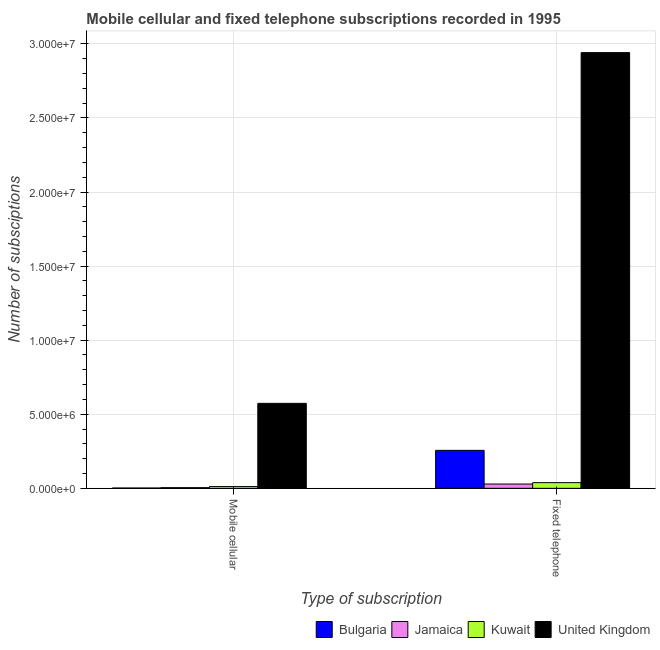How many different coloured bars are there?
Provide a short and direct response. 4. How many groups of bars are there?
Your answer should be compact. 2. Are the number of bars on each tick of the X-axis equal?
Give a very brief answer. Yes. How many bars are there on the 1st tick from the left?
Provide a succinct answer. 4. What is the label of the 2nd group of bars from the left?
Offer a terse response. Fixed telephone. What is the number of mobile cellular subscriptions in Jamaica?
Your answer should be compact. 4.51e+04. Across all countries, what is the maximum number of mobile cellular subscriptions?
Your answer should be very brief. 5.74e+06. Across all countries, what is the minimum number of fixed telephone subscriptions?
Provide a succinct answer. 2.90e+05. In which country was the number of fixed telephone subscriptions minimum?
Provide a short and direct response. Jamaica. What is the total number of mobile cellular subscriptions in the graph?
Your response must be concise. 5.92e+06. What is the difference between the number of fixed telephone subscriptions in United Kingdom and that in Bulgaria?
Give a very brief answer. 2.68e+07. What is the difference between the number of mobile cellular subscriptions in United Kingdom and the number of fixed telephone subscriptions in Jamaica?
Your answer should be compact. 5.45e+06. What is the average number of fixed telephone subscriptions per country?
Your response must be concise. 8.16e+06. What is the difference between the number of mobile cellular subscriptions and number of fixed telephone subscriptions in Jamaica?
Provide a short and direct response. -2.45e+05. In how many countries, is the number of fixed telephone subscriptions greater than 21000000 ?
Keep it short and to the point. 1. What is the ratio of the number of fixed telephone subscriptions in United Kingdom to that in Kuwait?
Keep it short and to the point. 76.94. Is the number of mobile cellular subscriptions in United Kingdom less than that in Jamaica?
Your answer should be compact. No. In how many countries, is the number of fixed telephone subscriptions greater than the average number of fixed telephone subscriptions taken over all countries?
Your response must be concise. 1. What does the 2nd bar from the left in Fixed telephone represents?
Your response must be concise. Jamaica. What does the 2nd bar from the right in Fixed telephone represents?
Provide a succinct answer. Kuwait. What is the difference between two consecutive major ticks on the Y-axis?
Offer a terse response. 5.00e+06. How many legend labels are there?
Your answer should be very brief. 4. How are the legend labels stacked?
Offer a terse response. Horizontal. What is the title of the graph?
Keep it short and to the point. Mobile cellular and fixed telephone subscriptions recorded in 1995. Does "Samoa" appear as one of the legend labels in the graph?
Offer a terse response. No. What is the label or title of the X-axis?
Ensure brevity in your answer.  Type of subscription. What is the label or title of the Y-axis?
Give a very brief answer. Number of subsciptions. What is the Number of subsciptions of Bulgaria in Mobile cellular?
Provide a short and direct response. 2.09e+04. What is the Number of subsciptions in Jamaica in Mobile cellular?
Provide a short and direct response. 4.51e+04. What is the Number of subsciptions in Kuwait in Mobile cellular?
Provide a short and direct response. 1.18e+05. What is the Number of subsciptions in United Kingdom in Mobile cellular?
Offer a very short reply. 5.74e+06. What is the Number of subsciptions of Bulgaria in Fixed telephone?
Provide a succinct answer. 2.56e+06. What is the Number of subsciptions of Jamaica in Fixed telephone?
Your answer should be compact. 2.90e+05. What is the Number of subsciptions in Kuwait in Fixed telephone?
Give a very brief answer. 3.82e+05. What is the Number of subsciptions of United Kingdom in Fixed telephone?
Ensure brevity in your answer.  2.94e+07. Across all Type of subscription, what is the maximum Number of subsciptions in Bulgaria?
Your answer should be very brief. 2.56e+06. Across all Type of subscription, what is the maximum Number of subsciptions of Jamaica?
Give a very brief answer. 2.90e+05. Across all Type of subscription, what is the maximum Number of subsciptions in Kuwait?
Your answer should be very brief. 3.82e+05. Across all Type of subscription, what is the maximum Number of subsciptions in United Kingdom?
Your answer should be compact. 2.94e+07. Across all Type of subscription, what is the minimum Number of subsciptions in Bulgaria?
Your answer should be very brief. 2.09e+04. Across all Type of subscription, what is the minimum Number of subsciptions of Jamaica?
Your response must be concise. 4.51e+04. Across all Type of subscription, what is the minimum Number of subsciptions of Kuwait?
Provide a short and direct response. 1.18e+05. Across all Type of subscription, what is the minimum Number of subsciptions in United Kingdom?
Provide a short and direct response. 5.74e+06. What is the total Number of subsciptions in Bulgaria in the graph?
Ensure brevity in your answer.  2.58e+06. What is the total Number of subsciptions of Jamaica in the graph?
Your response must be concise. 3.35e+05. What is the total Number of subsciptions of Kuwait in the graph?
Give a very brief answer. 5.00e+05. What is the total Number of subsciptions in United Kingdom in the graph?
Your answer should be compact. 3.51e+07. What is the difference between the Number of subsciptions of Bulgaria in Mobile cellular and that in Fixed telephone?
Keep it short and to the point. -2.54e+06. What is the difference between the Number of subsciptions in Jamaica in Mobile cellular and that in Fixed telephone?
Offer a very short reply. -2.45e+05. What is the difference between the Number of subsciptions in Kuwait in Mobile cellular and that in Fixed telephone?
Provide a short and direct response. -2.65e+05. What is the difference between the Number of subsciptions in United Kingdom in Mobile cellular and that in Fixed telephone?
Your answer should be very brief. -2.37e+07. What is the difference between the Number of subsciptions of Bulgaria in Mobile cellular and the Number of subsciptions of Jamaica in Fixed telephone?
Give a very brief answer. -2.69e+05. What is the difference between the Number of subsciptions in Bulgaria in Mobile cellular and the Number of subsciptions in Kuwait in Fixed telephone?
Provide a short and direct response. -3.61e+05. What is the difference between the Number of subsciptions in Bulgaria in Mobile cellular and the Number of subsciptions in United Kingdom in Fixed telephone?
Provide a short and direct response. -2.94e+07. What is the difference between the Number of subsciptions of Jamaica in Mobile cellular and the Number of subsciptions of Kuwait in Fixed telephone?
Offer a terse response. -3.37e+05. What is the difference between the Number of subsciptions of Jamaica in Mobile cellular and the Number of subsciptions of United Kingdom in Fixed telephone?
Ensure brevity in your answer.  -2.94e+07. What is the difference between the Number of subsciptions in Kuwait in Mobile cellular and the Number of subsciptions in United Kingdom in Fixed telephone?
Give a very brief answer. -2.93e+07. What is the average Number of subsciptions in Bulgaria per Type of subscription?
Make the answer very short. 1.29e+06. What is the average Number of subsciptions in Jamaica per Type of subscription?
Offer a very short reply. 1.68e+05. What is the average Number of subsciptions of Kuwait per Type of subscription?
Your response must be concise. 2.50e+05. What is the average Number of subsciptions in United Kingdom per Type of subscription?
Provide a short and direct response. 1.76e+07. What is the difference between the Number of subsciptions in Bulgaria and Number of subsciptions in Jamaica in Mobile cellular?
Offer a very short reply. -2.42e+04. What is the difference between the Number of subsciptions of Bulgaria and Number of subsciptions of Kuwait in Mobile cellular?
Ensure brevity in your answer.  -9.67e+04. What is the difference between the Number of subsciptions in Bulgaria and Number of subsciptions in United Kingdom in Mobile cellular?
Offer a terse response. -5.71e+06. What is the difference between the Number of subsciptions of Jamaica and Number of subsciptions of Kuwait in Mobile cellular?
Offer a very short reply. -7.25e+04. What is the difference between the Number of subsciptions in Jamaica and Number of subsciptions in United Kingdom in Mobile cellular?
Provide a short and direct response. -5.69e+06. What is the difference between the Number of subsciptions of Kuwait and Number of subsciptions of United Kingdom in Mobile cellular?
Your answer should be very brief. -5.62e+06. What is the difference between the Number of subsciptions of Bulgaria and Number of subsciptions of Jamaica in Fixed telephone?
Provide a short and direct response. 2.27e+06. What is the difference between the Number of subsciptions in Bulgaria and Number of subsciptions in Kuwait in Fixed telephone?
Ensure brevity in your answer.  2.18e+06. What is the difference between the Number of subsciptions in Bulgaria and Number of subsciptions in United Kingdom in Fixed telephone?
Keep it short and to the point. -2.68e+07. What is the difference between the Number of subsciptions of Jamaica and Number of subsciptions of Kuwait in Fixed telephone?
Make the answer very short. -9.20e+04. What is the difference between the Number of subsciptions in Jamaica and Number of subsciptions in United Kingdom in Fixed telephone?
Your answer should be compact. -2.91e+07. What is the difference between the Number of subsciptions of Kuwait and Number of subsciptions of United Kingdom in Fixed telephone?
Ensure brevity in your answer.  -2.90e+07. What is the ratio of the Number of subsciptions of Bulgaria in Mobile cellular to that in Fixed telephone?
Your answer should be very brief. 0.01. What is the ratio of the Number of subsciptions in Jamaica in Mobile cellular to that in Fixed telephone?
Provide a succinct answer. 0.16. What is the ratio of the Number of subsciptions in Kuwait in Mobile cellular to that in Fixed telephone?
Provide a succinct answer. 0.31. What is the ratio of the Number of subsciptions in United Kingdom in Mobile cellular to that in Fixed telephone?
Offer a very short reply. 0.2. What is the difference between the highest and the second highest Number of subsciptions of Bulgaria?
Your response must be concise. 2.54e+06. What is the difference between the highest and the second highest Number of subsciptions in Jamaica?
Make the answer very short. 2.45e+05. What is the difference between the highest and the second highest Number of subsciptions in Kuwait?
Provide a succinct answer. 2.65e+05. What is the difference between the highest and the second highest Number of subsciptions of United Kingdom?
Provide a short and direct response. 2.37e+07. What is the difference between the highest and the lowest Number of subsciptions of Bulgaria?
Offer a very short reply. 2.54e+06. What is the difference between the highest and the lowest Number of subsciptions of Jamaica?
Your response must be concise. 2.45e+05. What is the difference between the highest and the lowest Number of subsciptions of Kuwait?
Your answer should be very brief. 2.65e+05. What is the difference between the highest and the lowest Number of subsciptions in United Kingdom?
Give a very brief answer. 2.37e+07. 